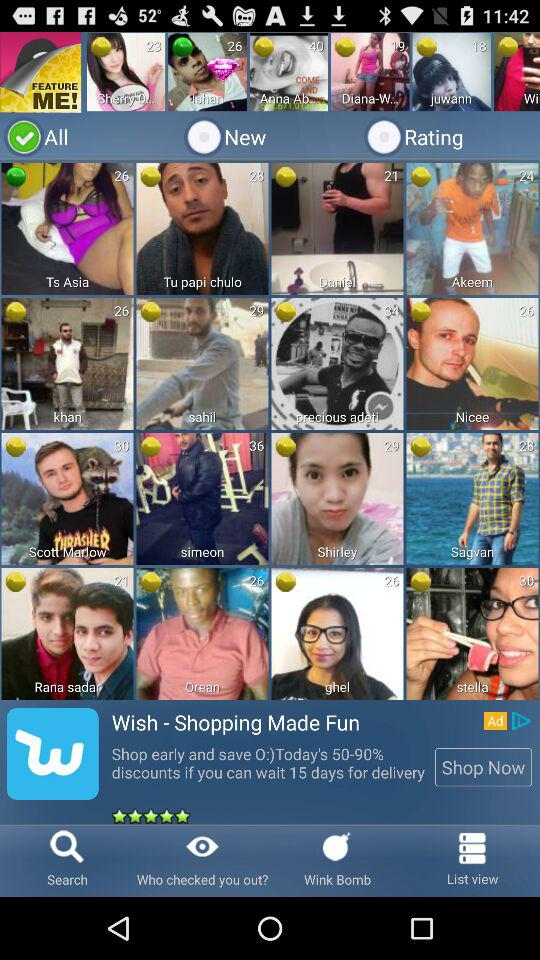How many items are in "New"?
When the provided information is insufficient, respond with <no answer>. <no answer> 